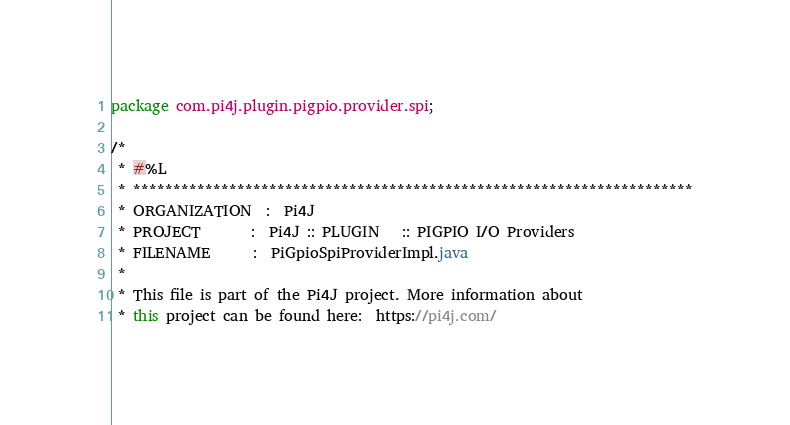Convert code to text. <code><loc_0><loc_0><loc_500><loc_500><_Java_>package com.pi4j.plugin.pigpio.provider.spi;

/*
 * #%L
 * **********************************************************************
 * ORGANIZATION  :  Pi4J
 * PROJECT       :  Pi4J :: PLUGIN   :: PIGPIO I/O Providers
 * FILENAME      :  PiGpioSpiProviderImpl.java
 *
 * This file is part of the Pi4J project. More information about
 * this project can be found here:  https://pi4j.com/</code> 